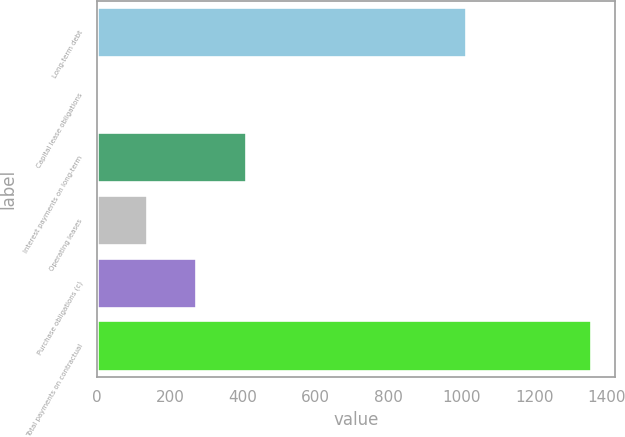Convert chart to OTSL. <chart><loc_0><loc_0><loc_500><loc_500><bar_chart><fcel>Long-term debt<fcel>Capital lease obligations<fcel>Interest payments on long-term<fcel>Operating leases<fcel>Purchase obligations (c)<fcel>Total payments on contractual<nl><fcel>1011.8<fcel>2.1<fcel>407.97<fcel>137.39<fcel>272.68<fcel>1355<nl></chart> 